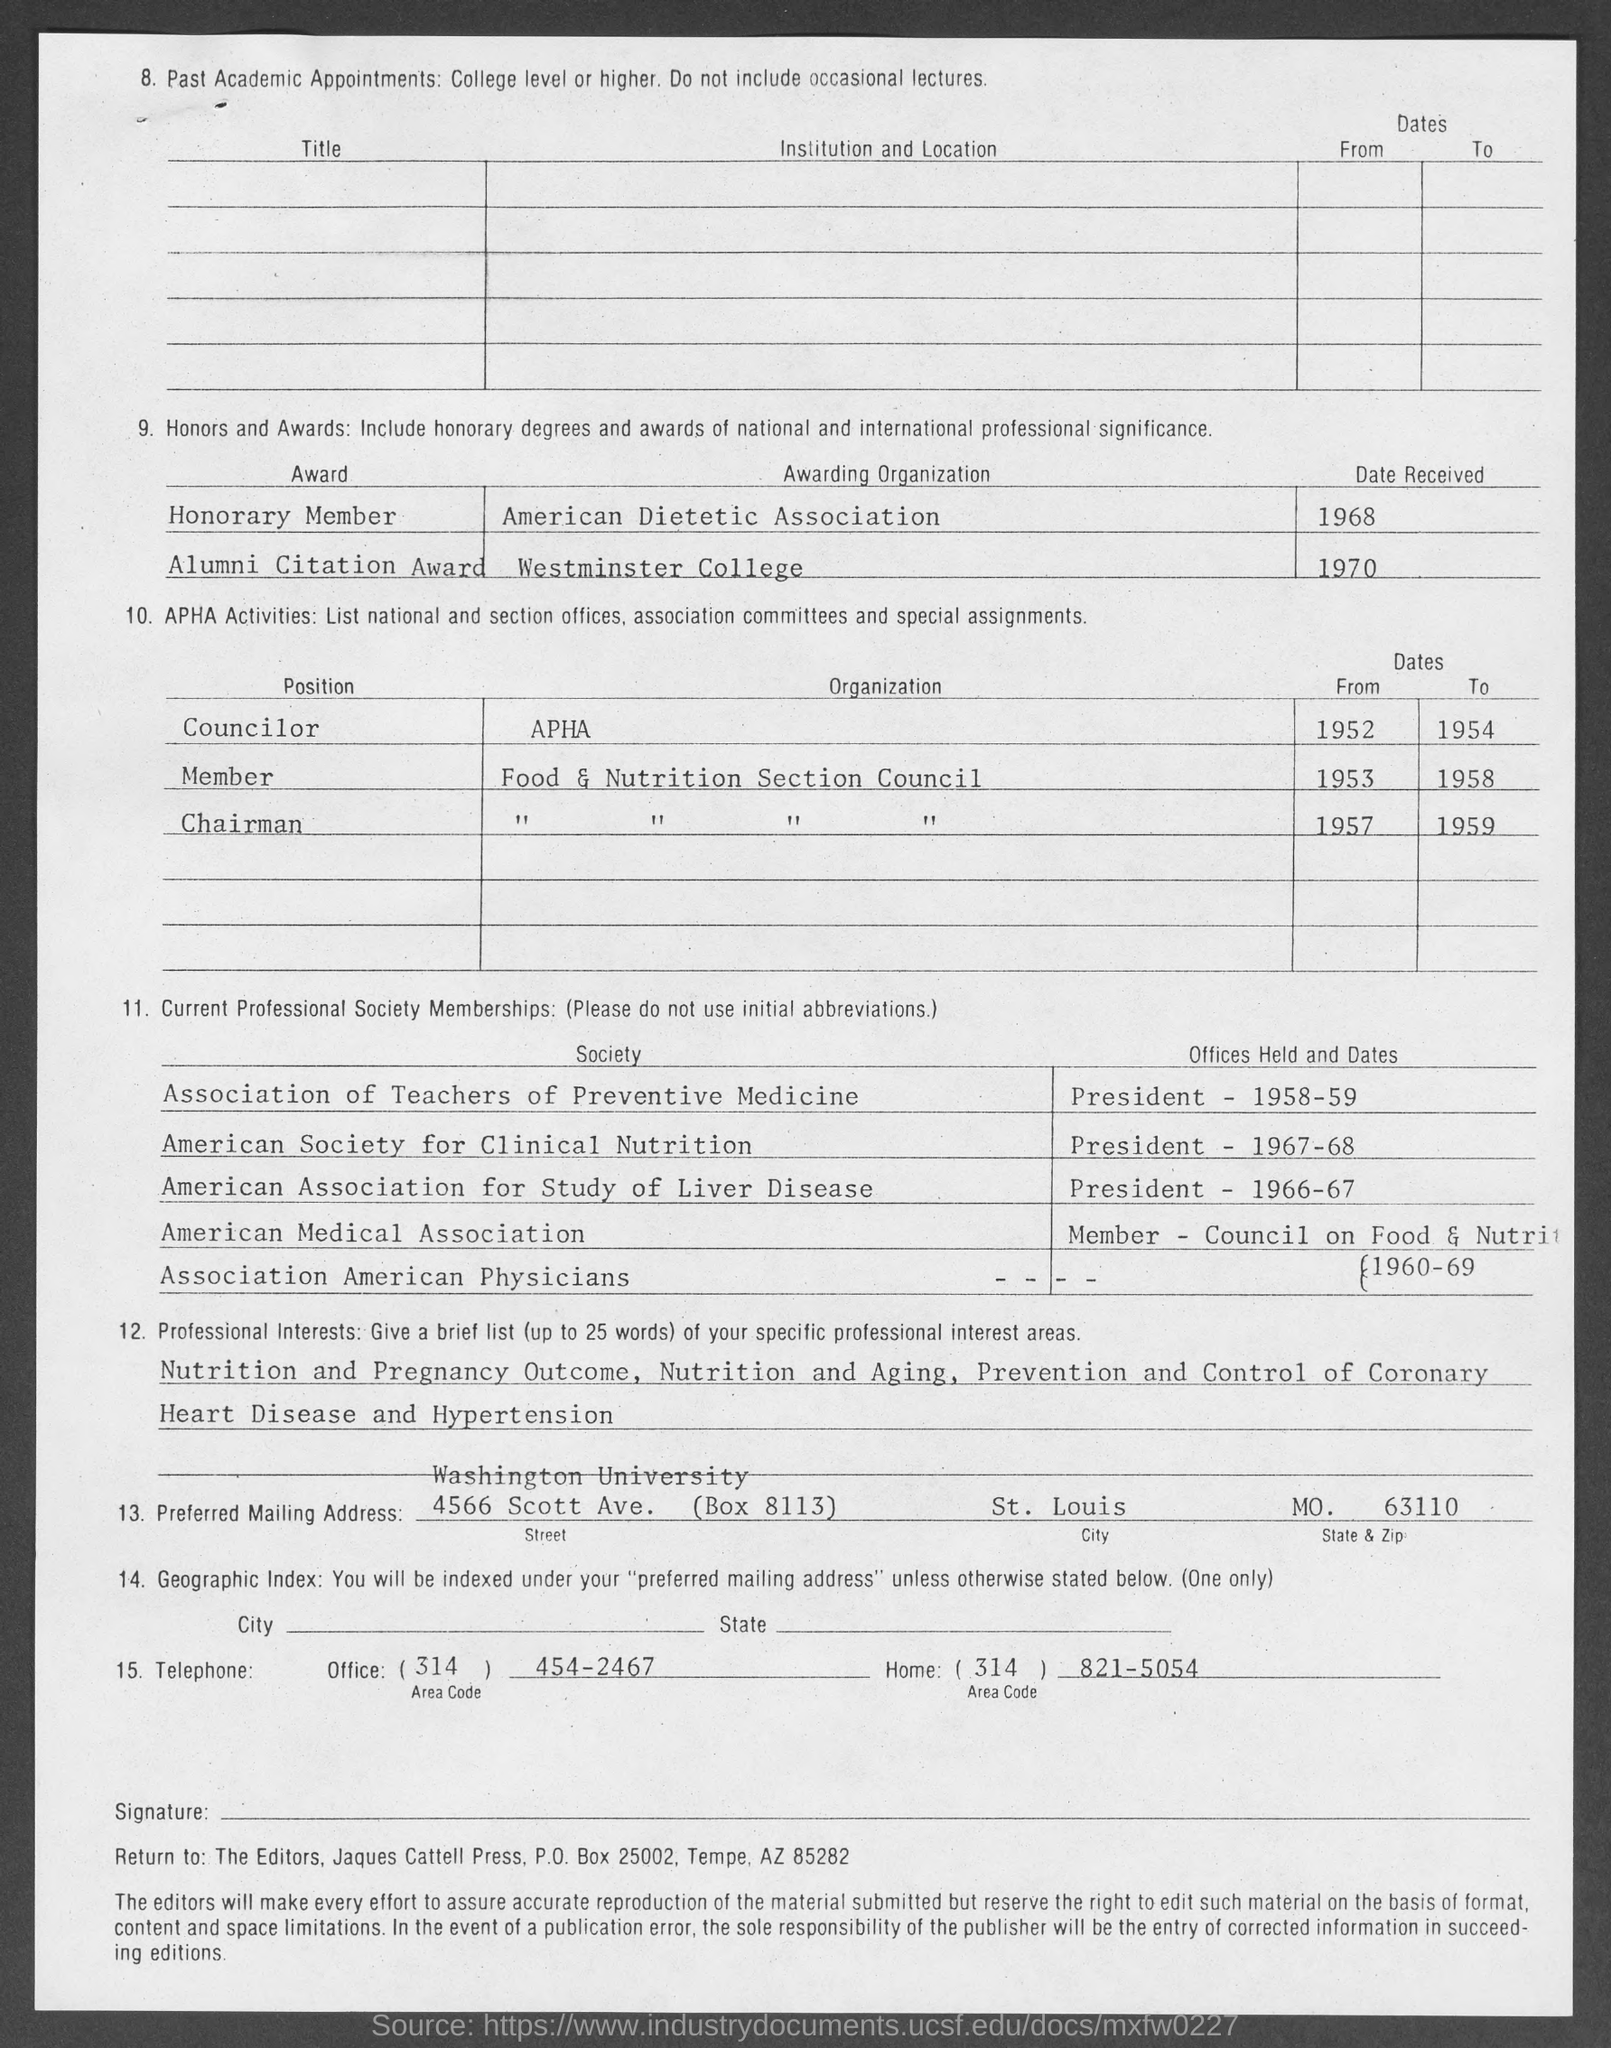Can you tell me more about the professional societies the individual is a member of? This individual is a member of several notable professional societies, including the Association of Teachers of Preventive Medicine, the American Society for Clinical Nutrition, and the American Association for Study of Liver Disease, among others. These memberships suggest a focus on clinical nutrition and preventive medicine. 